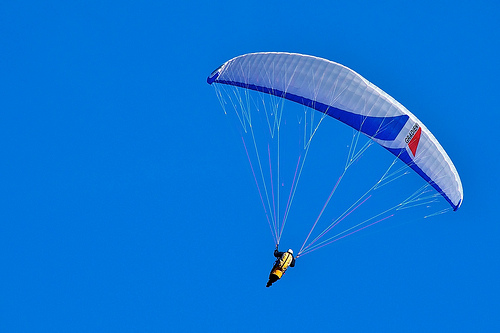Can you narrate a fictional adventure involving the person in the image? The person in the image is an adventurer named Alex who discovered an ancient map leading to a hidden treasure believed to be buried in a remote, uncharted island. Determined to uncover its secrets, Alex embarked on a daring paragliding expedition to reach this mysterious island. With the wind guiding their path, Alex soared above treacherous mountains and dense forests, encountering unexpected challenges along the way.

One day, amidst a brilliant blue sky, Alex noticed a peculiar formation in the cliffs below - the shape of an eagle that perfectly matched a clue from the map. With heart pounding and adrenaline rushing, Alex navigated towards the cliffs, skillfully maneuvering the parachute. Upon landing on a narrow ledge, Alex discovered a hidden cave entrance concealed behind a cascading waterfall.

Inside the cave, ancient inscriptions and artifacts revealed the history of a long-lost civilization that once thrived on the island. Following the intricate maze of tunnels and chambers, Alex overcame numerous obstacles and deciphered cryptic messages, each step bringing them closer to the treasure. At last, in the heart of the cave, Alex found a chest filled with glittering jewels and priceless relics, the legacy of the ancient civilization.

With the treasure secured and a sense of accomplishment, Alex soared back into the sky, carrying not just the tangible rewards, but also the stories and memories of an unforgettable adventure. This journey had not only fulfilled a quest for treasure but had also connected Alex to the mysteries of the past, leaving an indelible mark on their soul. 